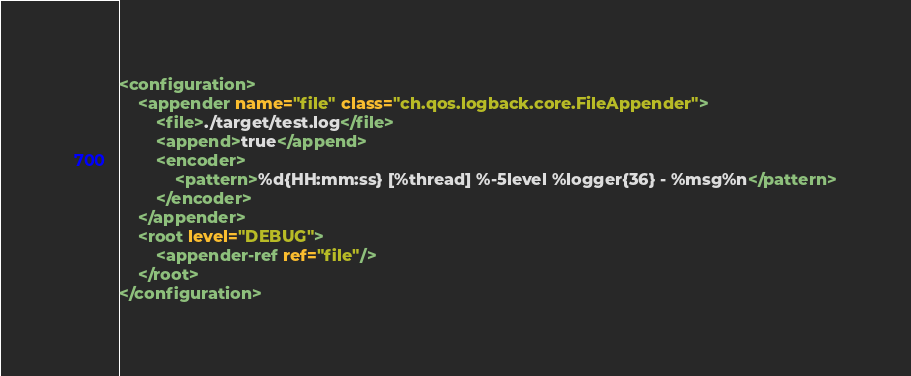Convert code to text. <code><loc_0><loc_0><loc_500><loc_500><_XML_><configuration>
    <appender name="file" class="ch.qos.logback.core.FileAppender">
        <file>./target/test.log</file>
        <append>true</append>
        <encoder>
            <pattern>%d{HH:mm:ss} [%thread] %-5level %logger{36} - %msg%n</pattern>
        </encoder>
    </appender>
    <root level="DEBUG">
        <appender-ref ref="file"/>
    </root>
</configuration></code> 